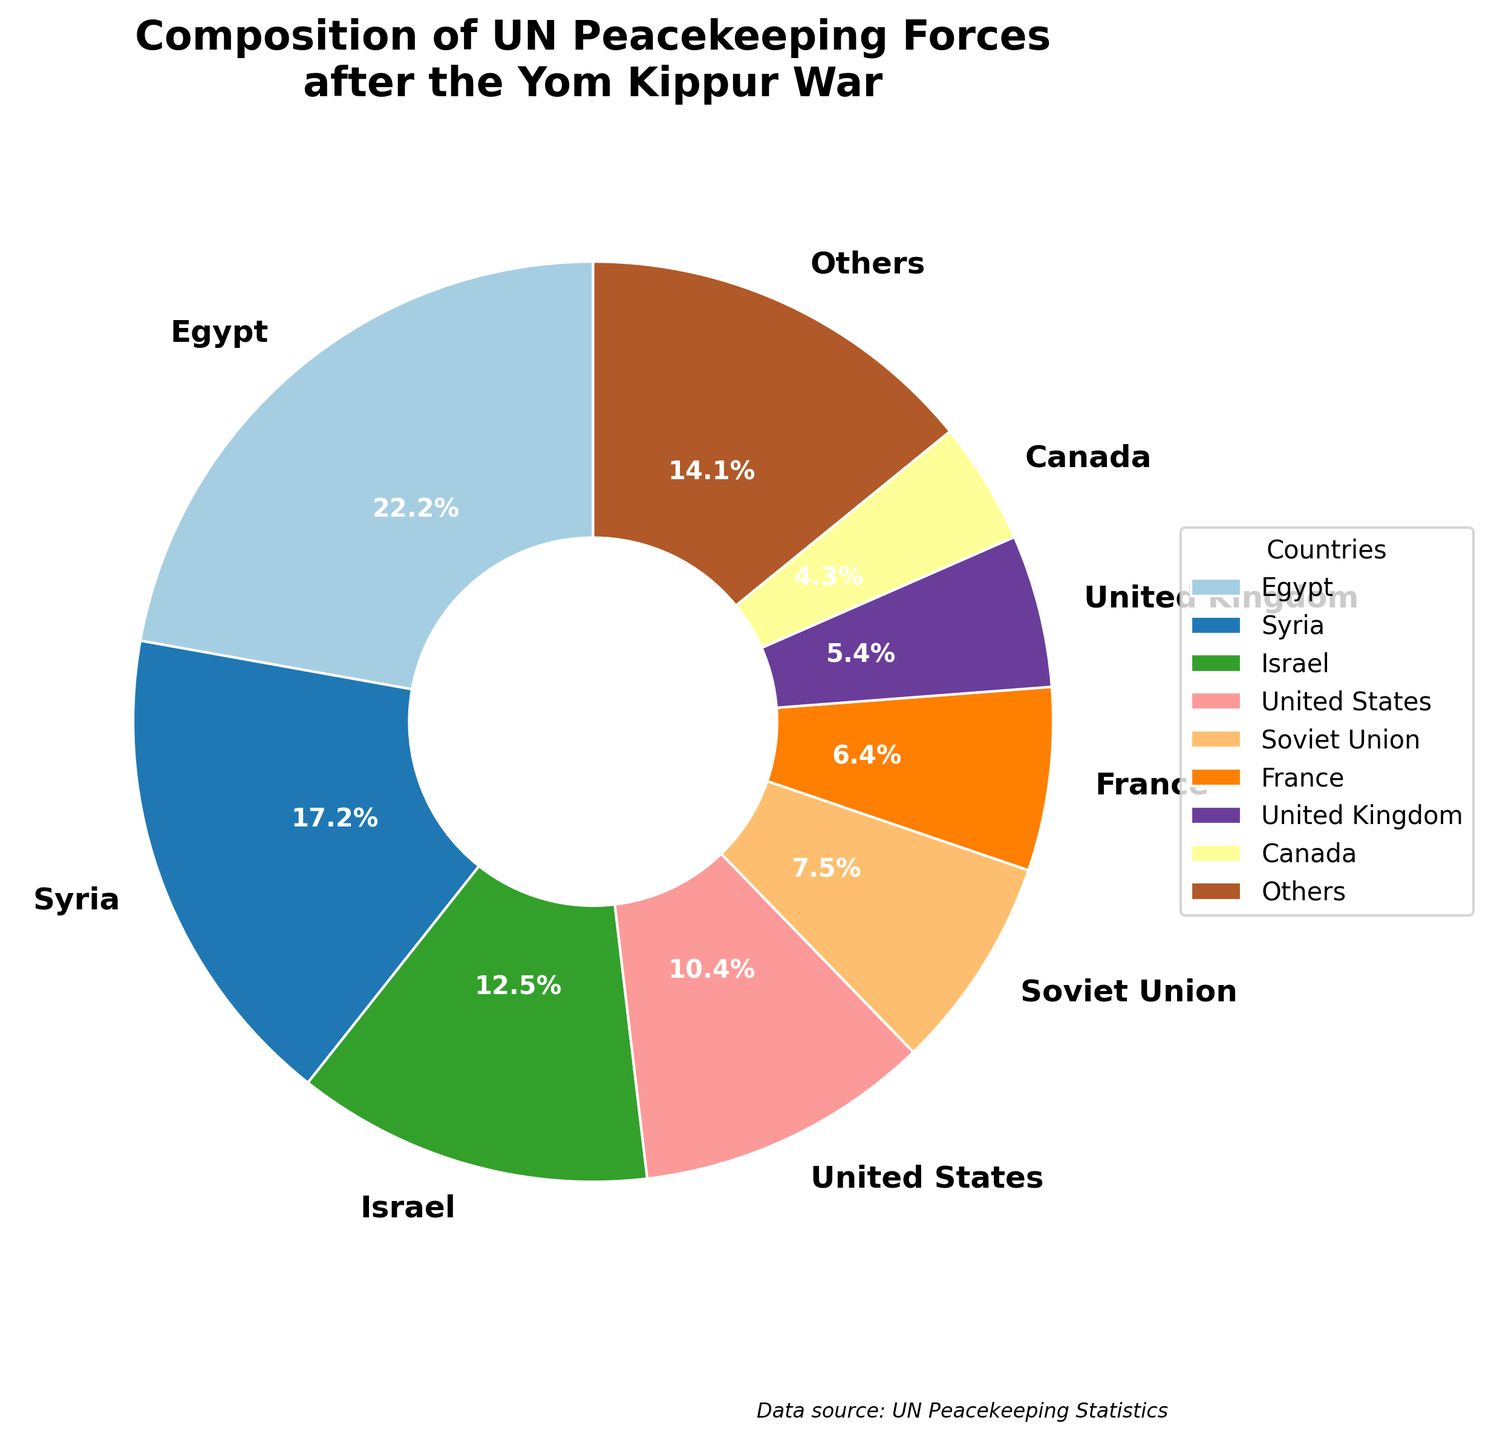Which country contributes the most to the UN peacekeeping forces? The largest slice in the pie chart represents the country with the highest number of peacekeepers.
Answer: Egypt What is the percentage contribution of the United States to the UN peacekeeping forces? Check the label associated with the United States slice in the pie chart to find its percentage.
Answer: 9.3% How much larger (in percentage points) is Egypt's contribution compared to Syria's? Find the percentages for both Egypt and Syria from the chart, then subtract Syria's percentage from Egypt's percentage.
Answer: 8.8% Which country has a larger contribution, the Soviet Union or France, and by how much (in percentage points)? Locate the percentages for the Soviet Union and France on the chart and subtract France's percentage from the Soviet Union's percentage.
Answer: Soviet Union by 3.8% What is the combined percentage of peacekeepers contributed by the United Kingdom and Canada? Add the percentages of the United Kingdom and Canada from the chart together.
Answer: 7.5% What is the total percentage of peacekeepers contributed by the top three countries? Add the percentages of Egypt, Syria, and Israel, which are the top three countries in the chart.
Answer: 45.6% How does the contribution of "Others" compare to Egypt's contribution in percentage terms? Look at the "Others" slice percentage and compare it directly with Egypt's percentage.
Answer: "Others" is 16.3%, Egypt is 16.3% What color represents the contribution of Indonesia in the pie chart? Identify the color slice associated with Indonesia by finding the label on the chart.
Answer: Greenish-yellow (actual colors may vary, refer to the nearest visual description) Which countries contribute almost equal percentages to the UN peacekeeping forces and what are their contributions? Look for countries with close or equal percentage numbers on the chart.
Answer: Sweden (1.3%) and Finland (1.2%) How much smaller is France's contribution compared to the combined contribution of Nepal and Indonesia? Find the percentages for France, Nepal, and Indonesia, add Nepal's and Indonesia's percentages together, then subtract France's percentage.
Answer: (2.3% + 2.5%) - 4.7% = 0.1% 